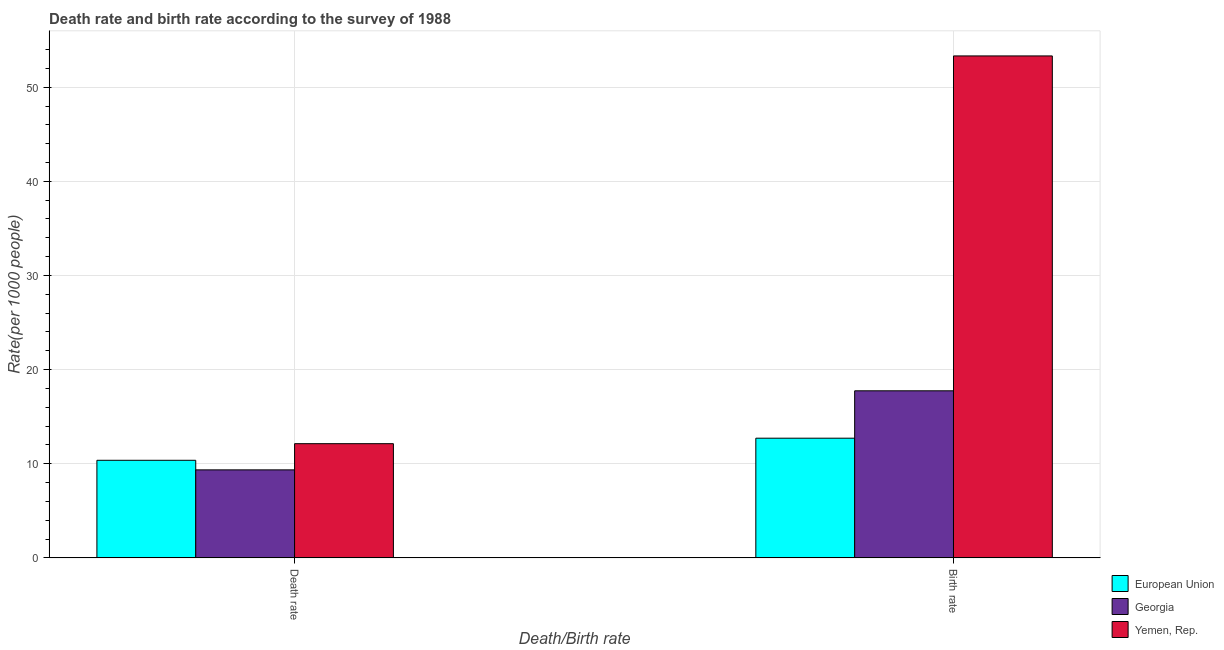Are the number of bars per tick equal to the number of legend labels?
Your answer should be compact. Yes. Are the number of bars on each tick of the X-axis equal?
Your answer should be very brief. Yes. How many bars are there on the 2nd tick from the left?
Ensure brevity in your answer.  3. How many bars are there on the 2nd tick from the right?
Your answer should be very brief. 3. What is the label of the 2nd group of bars from the left?
Offer a terse response. Birth rate. What is the death rate in Georgia?
Offer a very short reply. 9.35. Across all countries, what is the maximum birth rate?
Ensure brevity in your answer.  53.32. Across all countries, what is the minimum birth rate?
Offer a very short reply. 12.72. In which country was the birth rate maximum?
Your answer should be very brief. Yemen, Rep. In which country was the death rate minimum?
Offer a very short reply. Georgia. What is the total birth rate in the graph?
Offer a terse response. 83.78. What is the difference between the death rate in Georgia and that in European Union?
Your response must be concise. -1.02. What is the difference between the birth rate in Yemen, Rep. and the death rate in European Union?
Offer a very short reply. 42.95. What is the average death rate per country?
Keep it short and to the point. 10.62. What is the difference between the death rate and birth rate in Yemen, Rep.?
Offer a very short reply. -41.19. In how many countries, is the death rate greater than 14 ?
Offer a very short reply. 0. What is the ratio of the birth rate in Georgia to that in European Union?
Your answer should be very brief. 1.4. Is the birth rate in Georgia less than that in Yemen, Rep.?
Provide a short and direct response. Yes. In how many countries, is the death rate greater than the average death rate taken over all countries?
Provide a short and direct response. 1. What does the 3rd bar from the left in Birth rate represents?
Offer a very short reply. Yemen, Rep. What does the 1st bar from the right in Death rate represents?
Offer a terse response. Yemen, Rep. How many bars are there?
Provide a succinct answer. 6. How many countries are there in the graph?
Keep it short and to the point. 3. What is the difference between two consecutive major ticks on the Y-axis?
Your answer should be very brief. 10. Are the values on the major ticks of Y-axis written in scientific E-notation?
Offer a terse response. No. Does the graph contain any zero values?
Offer a very short reply. No. Where does the legend appear in the graph?
Give a very brief answer. Bottom right. How are the legend labels stacked?
Your answer should be compact. Vertical. What is the title of the graph?
Offer a very short reply. Death rate and birth rate according to the survey of 1988. What is the label or title of the X-axis?
Your response must be concise. Death/Birth rate. What is the label or title of the Y-axis?
Your answer should be very brief. Rate(per 1000 people). What is the Rate(per 1000 people) in European Union in Death rate?
Provide a short and direct response. 10.37. What is the Rate(per 1000 people) in Georgia in Death rate?
Keep it short and to the point. 9.35. What is the Rate(per 1000 people) in Yemen, Rep. in Death rate?
Make the answer very short. 12.13. What is the Rate(per 1000 people) in European Union in Birth rate?
Keep it short and to the point. 12.72. What is the Rate(per 1000 people) in Georgia in Birth rate?
Make the answer very short. 17.75. What is the Rate(per 1000 people) in Yemen, Rep. in Birth rate?
Give a very brief answer. 53.32. Across all Death/Birth rate, what is the maximum Rate(per 1000 people) in European Union?
Provide a short and direct response. 12.72. Across all Death/Birth rate, what is the maximum Rate(per 1000 people) in Georgia?
Offer a very short reply. 17.75. Across all Death/Birth rate, what is the maximum Rate(per 1000 people) of Yemen, Rep.?
Provide a short and direct response. 53.32. Across all Death/Birth rate, what is the minimum Rate(per 1000 people) in European Union?
Provide a short and direct response. 10.37. Across all Death/Birth rate, what is the minimum Rate(per 1000 people) of Georgia?
Ensure brevity in your answer.  9.35. Across all Death/Birth rate, what is the minimum Rate(per 1000 people) of Yemen, Rep.?
Offer a very short reply. 12.13. What is the total Rate(per 1000 people) in European Union in the graph?
Offer a terse response. 23.08. What is the total Rate(per 1000 people) in Georgia in the graph?
Offer a very short reply. 27.1. What is the total Rate(per 1000 people) in Yemen, Rep. in the graph?
Your answer should be very brief. 65.45. What is the difference between the Rate(per 1000 people) of European Union in Death rate and that in Birth rate?
Your answer should be very brief. -2.35. What is the difference between the Rate(per 1000 people) of Georgia in Death rate and that in Birth rate?
Your answer should be very brief. -8.4. What is the difference between the Rate(per 1000 people) in Yemen, Rep. in Death rate and that in Birth rate?
Keep it short and to the point. -41.19. What is the difference between the Rate(per 1000 people) in European Union in Death rate and the Rate(per 1000 people) in Georgia in Birth rate?
Provide a short and direct response. -7.38. What is the difference between the Rate(per 1000 people) in European Union in Death rate and the Rate(per 1000 people) in Yemen, Rep. in Birth rate?
Your answer should be compact. -42.95. What is the difference between the Rate(per 1000 people) of Georgia in Death rate and the Rate(per 1000 people) of Yemen, Rep. in Birth rate?
Keep it short and to the point. -43.97. What is the average Rate(per 1000 people) in European Union per Death/Birth rate?
Provide a succinct answer. 11.54. What is the average Rate(per 1000 people) of Georgia per Death/Birth rate?
Ensure brevity in your answer.  13.55. What is the average Rate(per 1000 people) in Yemen, Rep. per Death/Birth rate?
Offer a terse response. 32.73. What is the difference between the Rate(per 1000 people) in European Union and Rate(per 1000 people) in Georgia in Death rate?
Make the answer very short. 1.02. What is the difference between the Rate(per 1000 people) in European Union and Rate(per 1000 people) in Yemen, Rep. in Death rate?
Offer a terse response. -1.76. What is the difference between the Rate(per 1000 people) in Georgia and Rate(per 1000 people) in Yemen, Rep. in Death rate?
Your answer should be compact. -2.78. What is the difference between the Rate(per 1000 people) in European Union and Rate(per 1000 people) in Georgia in Birth rate?
Your answer should be very brief. -5.03. What is the difference between the Rate(per 1000 people) in European Union and Rate(per 1000 people) in Yemen, Rep. in Birth rate?
Provide a succinct answer. -40.6. What is the difference between the Rate(per 1000 people) of Georgia and Rate(per 1000 people) of Yemen, Rep. in Birth rate?
Your response must be concise. -35.57. What is the ratio of the Rate(per 1000 people) of European Union in Death rate to that in Birth rate?
Provide a short and direct response. 0.82. What is the ratio of the Rate(per 1000 people) of Georgia in Death rate to that in Birth rate?
Give a very brief answer. 0.53. What is the ratio of the Rate(per 1000 people) of Yemen, Rep. in Death rate to that in Birth rate?
Keep it short and to the point. 0.23. What is the difference between the highest and the second highest Rate(per 1000 people) of European Union?
Keep it short and to the point. 2.35. What is the difference between the highest and the second highest Rate(per 1000 people) in Georgia?
Keep it short and to the point. 8.4. What is the difference between the highest and the second highest Rate(per 1000 people) in Yemen, Rep.?
Keep it short and to the point. 41.19. What is the difference between the highest and the lowest Rate(per 1000 people) in European Union?
Provide a short and direct response. 2.35. What is the difference between the highest and the lowest Rate(per 1000 people) in Georgia?
Your answer should be compact. 8.4. What is the difference between the highest and the lowest Rate(per 1000 people) of Yemen, Rep.?
Offer a terse response. 41.19. 